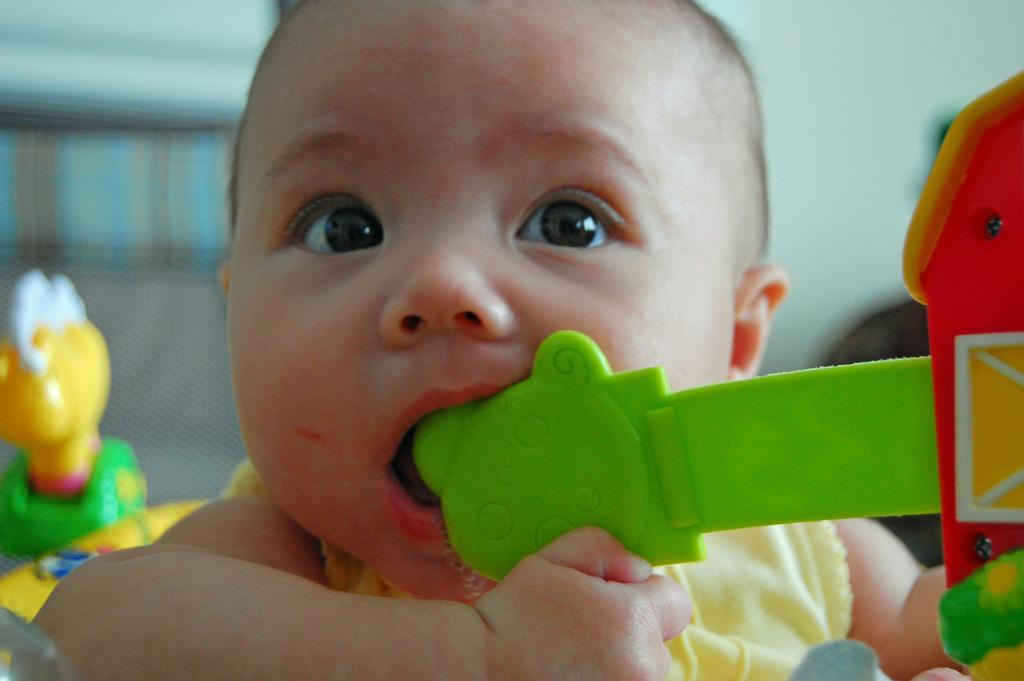What is the main subject of the image? There is a baby in the image. What is the baby doing in the image? The baby has a toy in its mouth. Are there any other toys visible in the image? Yes, there are other toys around the baby. Can you describe the background of the image? The background of the image is blurry. What advice is the baby giving to the person in the image? There is no person present in the image, and the baby is not giving any advice. What type of hammer is being used by the baby in the image? There is no hammer present in the image; the baby has a toy in its mouth. 